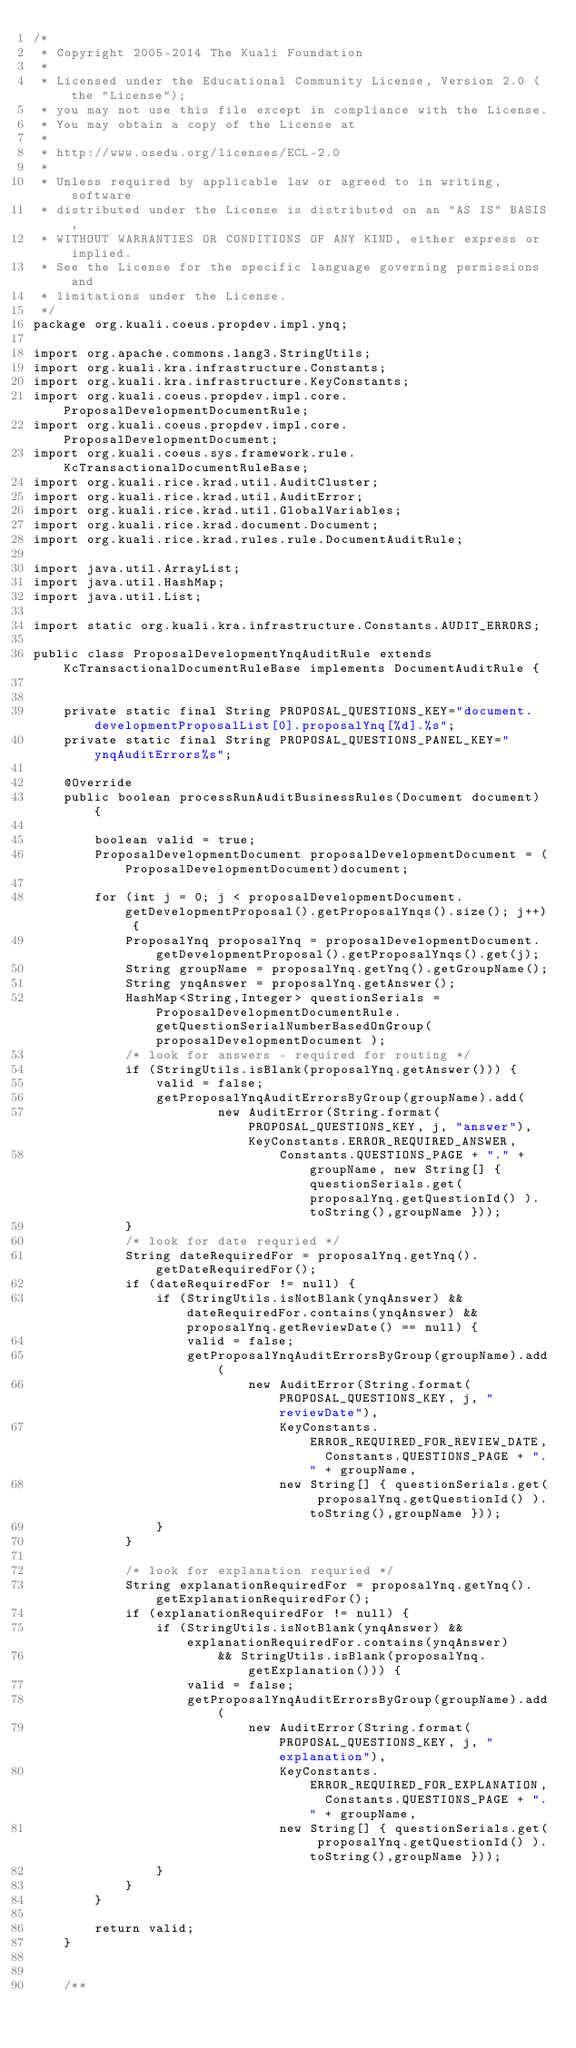<code> <loc_0><loc_0><loc_500><loc_500><_Java_>/*
 * Copyright 2005-2014 The Kuali Foundation
 * 
 * Licensed under the Educational Community License, Version 2.0 (the "License");
 * you may not use this file except in compliance with the License.
 * You may obtain a copy of the License at
 * 
 * http://www.osedu.org/licenses/ECL-2.0
 * 
 * Unless required by applicable law or agreed to in writing, software
 * distributed under the License is distributed on an "AS IS" BASIS,
 * WITHOUT WARRANTIES OR CONDITIONS OF ANY KIND, either express or implied.
 * See the License for the specific language governing permissions and
 * limitations under the License.
 */
package org.kuali.coeus.propdev.impl.ynq;

import org.apache.commons.lang3.StringUtils;
import org.kuali.kra.infrastructure.Constants;
import org.kuali.kra.infrastructure.KeyConstants;
import org.kuali.coeus.propdev.impl.core.ProposalDevelopmentDocumentRule;
import org.kuali.coeus.propdev.impl.core.ProposalDevelopmentDocument;
import org.kuali.coeus.sys.framework.rule.KcTransactionalDocumentRuleBase;
import org.kuali.rice.krad.util.AuditCluster;
import org.kuali.rice.krad.util.AuditError;
import org.kuali.rice.krad.util.GlobalVariables;
import org.kuali.rice.krad.document.Document;
import org.kuali.rice.krad.rules.rule.DocumentAuditRule;

import java.util.ArrayList;
import java.util.HashMap;
import java.util.List;

import static org.kuali.kra.infrastructure.Constants.AUDIT_ERRORS;

public class ProposalDevelopmentYnqAuditRule extends KcTransactionalDocumentRuleBase implements DocumentAuditRule {
   
    
    private static final String PROPOSAL_QUESTIONS_KEY="document.developmentProposalList[0].proposalYnq[%d].%s";
    private static final String PROPOSAL_QUESTIONS_PANEL_KEY="ynqAuditErrors%s";
    
    @Override
    public boolean processRunAuditBusinessRules(Document document) {
    
        boolean valid = true;
        ProposalDevelopmentDocument proposalDevelopmentDocument = (ProposalDevelopmentDocument)document;
        
        for (int j = 0; j < proposalDevelopmentDocument.getDevelopmentProposal().getProposalYnqs().size(); j++) {
            ProposalYnq proposalYnq = proposalDevelopmentDocument.getDevelopmentProposal().getProposalYnqs().get(j);
            String groupName = proposalYnq.getYnq().getGroupName();
            String ynqAnswer = proposalYnq.getAnswer();
            HashMap<String,Integer> questionSerials = ProposalDevelopmentDocumentRule.getQuestionSerialNumberBasedOnGroup( proposalDevelopmentDocument );
            /* look for answers - required for routing */
            if (StringUtils.isBlank(proposalYnq.getAnswer())) {
                valid = false;
                getProposalYnqAuditErrorsByGroup(groupName).add(
                        new AuditError(String.format(PROPOSAL_QUESTIONS_KEY, j, "answer"), KeyConstants.ERROR_REQUIRED_ANSWER,
                                Constants.QUESTIONS_PAGE + "." + groupName, new String[] { questionSerials.get( proposalYnq.getQuestionId() ).toString(),groupName }));
            }
            /* look for date requried */
            String dateRequiredFor = proposalYnq.getYnq().getDateRequiredFor();
            if (dateRequiredFor != null) {
                if (StringUtils.isNotBlank(ynqAnswer) && dateRequiredFor.contains(ynqAnswer) && proposalYnq.getReviewDate() == null) {
                    valid = false;
                    getProposalYnqAuditErrorsByGroup(groupName).add(
                            new AuditError(String.format(PROPOSAL_QUESTIONS_KEY, j, "reviewDate"),
                                KeyConstants.ERROR_REQUIRED_FOR_REVIEW_DATE,  Constants.QUESTIONS_PAGE + "." + groupName,
                                new String[] { questionSerials.get( proposalYnq.getQuestionId() ).toString(),groupName }));
                }
            }

            /* look for explanation requried */
            String explanationRequiredFor = proposalYnq.getYnq().getExplanationRequiredFor();
            if (explanationRequiredFor != null) {
                if (StringUtils.isNotBlank(ynqAnswer) && explanationRequiredFor.contains(ynqAnswer)
                        && StringUtils.isBlank(proposalYnq.getExplanation())) {
                    valid = false;
                    getProposalYnqAuditErrorsByGroup(groupName).add(
                            new AuditError(String.format(PROPOSAL_QUESTIONS_KEY, j, "explanation"),
                                KeyConstants.ERROR_REQUIRED_FOR_EXPLANATION,  Constants.QUESTIONS_PAGE + "." + groupName,
                                new String[] { questionSerials.get( proposalYnq.getQuestionId() ).toString(),groupName }));
                }
            }
        }

        return valid;
    }
    
   
    /**</code> 